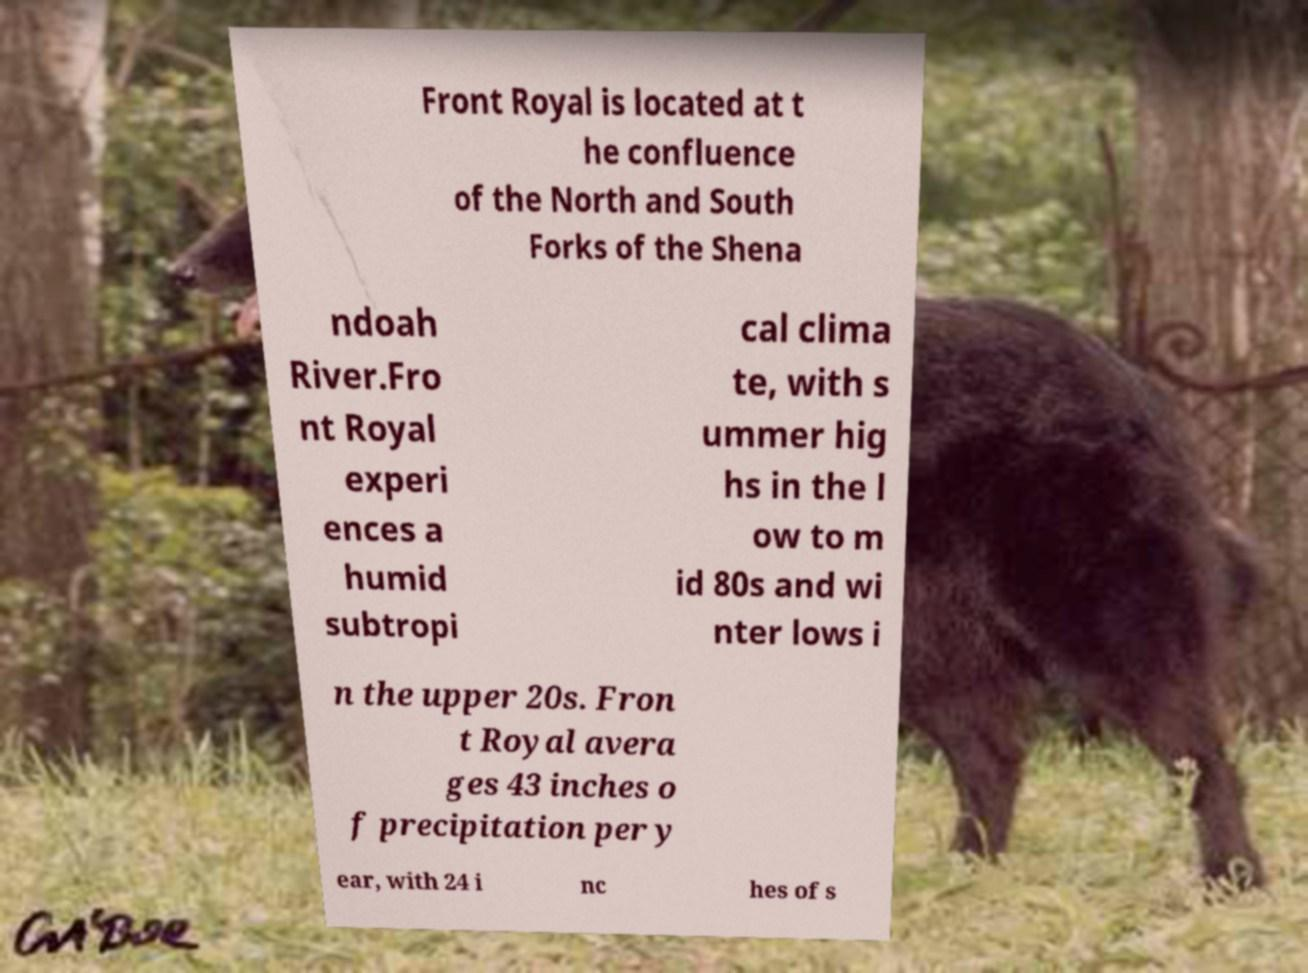Please read and relay the text visible in this image. What does it say? Front Royal is located at t he confluence of the North and South Forks of the Shena ndoah River.Fro nt Royal experi ences a humid subtropi cal clima te, with s ummer hig hs in the l ow to m id 80s and wi nter lows i n the upper 20s. Fron t Royal avera ges 43 inches o f precipitation per y ear, with 24 i nc hes of s 